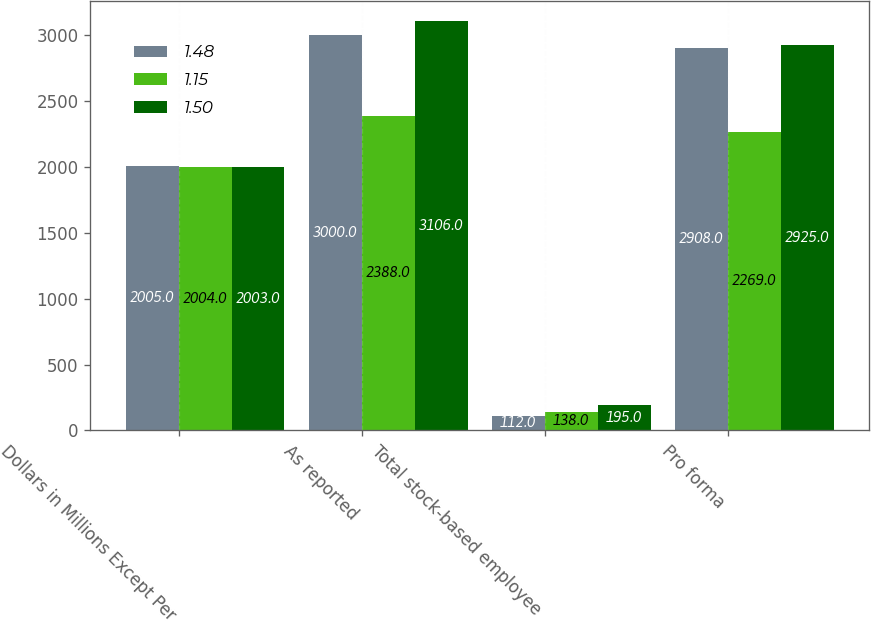Convert chart. <chart><loc_0><loc_0><loc_500><loc_500><stacked_bar_chart><ecel><fcel>Dollars in Millions Except Per<fcel>As reported<fcel>Total stock-based employee<fcel>Pro forma<nl><fcel>1.48<fcel>2005<fcel>3000<fcel>112<fcel>2908<nl><fcel>1.15<fcel>2004<fcel>2388<fcel>138<fcel>2269<nl><fcel>1.5<fcel>2003<fcel>3106<fcel>195<fcel>2925<nl></chart> 